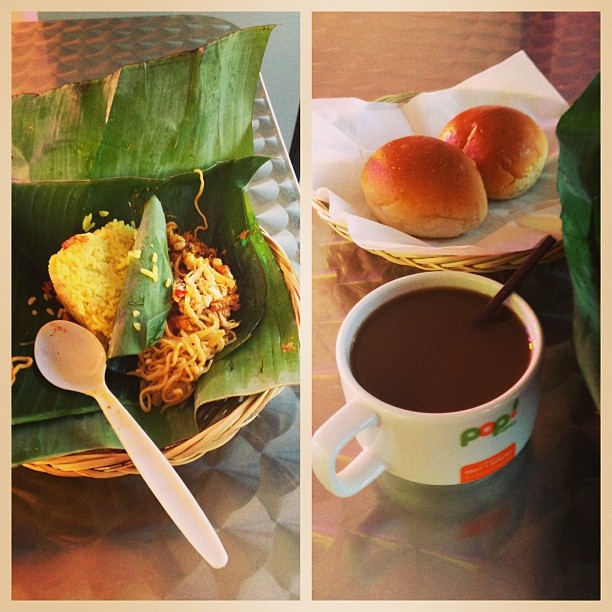Describe the objects in this image and their specific colors. I can see dining table in tan, black, maroon, and gray tones, cup in tan, maroon, and black tones, dining table in tan, maroon, brown, and gray tones, cake in tan, brown, red, and orange tones, and spoon in tan and lightgray tones in this image. 